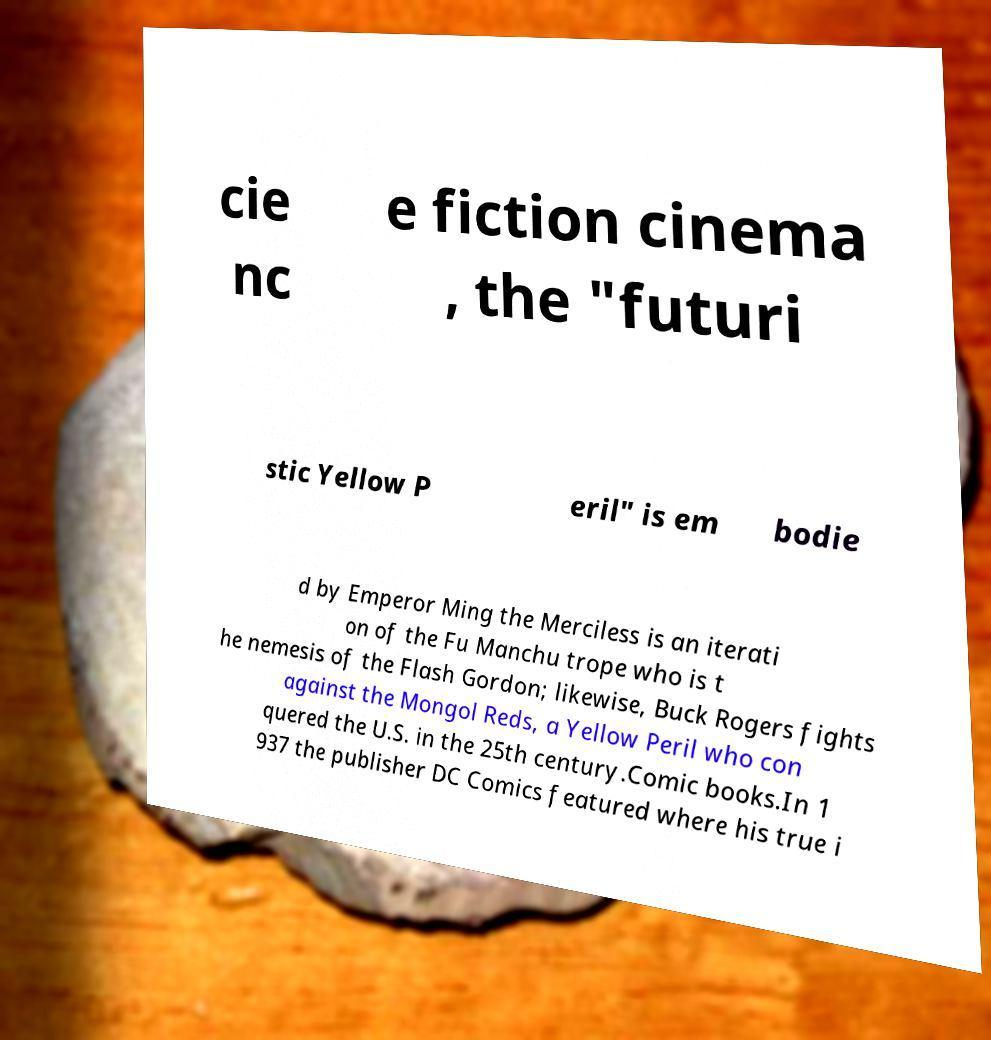For documentation purposes, I need the text within this image transcribed. Could you provide that? cie nc e fiction cinema , the "futuri stic Yellow P eril" is em bodie d by Emperor Ming the Merciless is an iterati on of the Fu Manchu trope who is t he nemesis of the Flash Gordon; likewise, Buck Rogers fights against the Mongol Reds, a Yellow Peril who con quered the U.S. in the 25th century.Comic books.In 1 937 the publisher DC Comics featured where his true i 